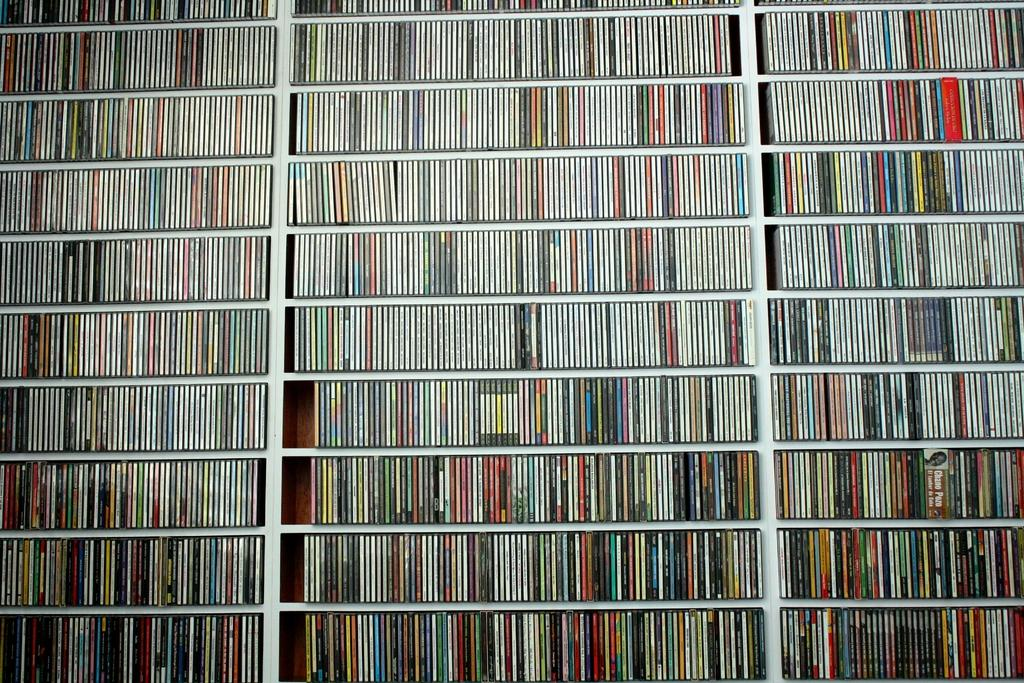What is the main object in the image? There is a big wooden rack in the image. What is the wooden rack filled with? The wooden rack is full of books. What type of drug is being stored on the wooden rack in the image? There is no drug present in the image; the wooden rack is full of books. 